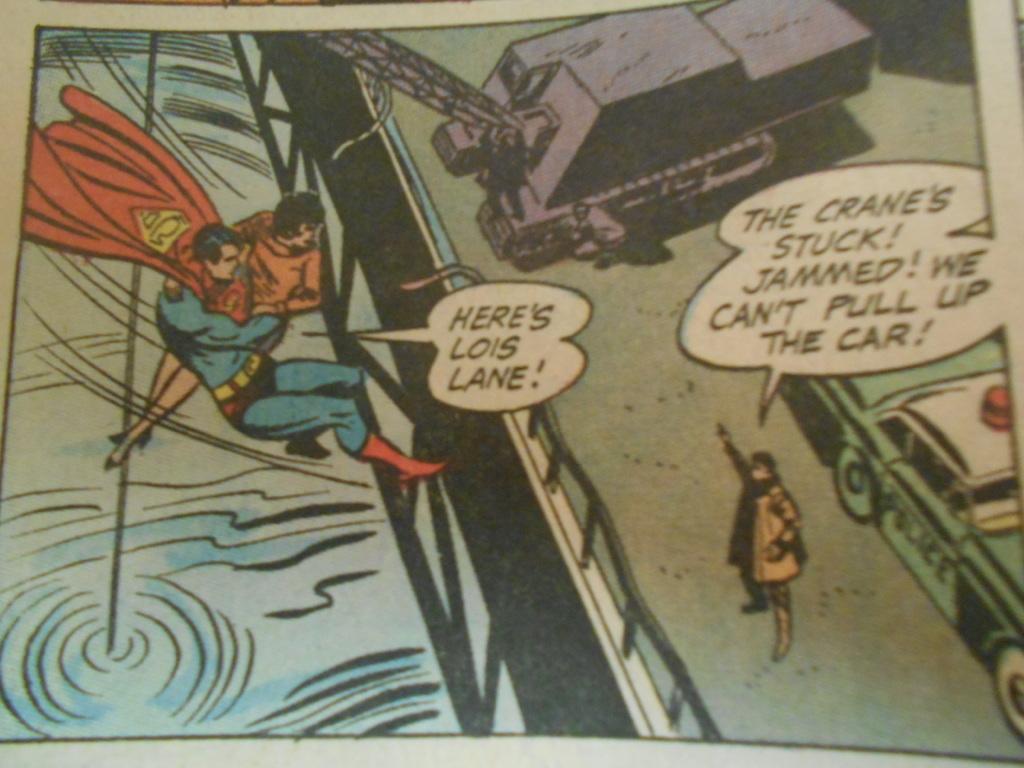Where's lois lane?
Your answer should be very brief. Here. Why can't she pull up the car?
Provide a short and direct response. The crane's stuck. 